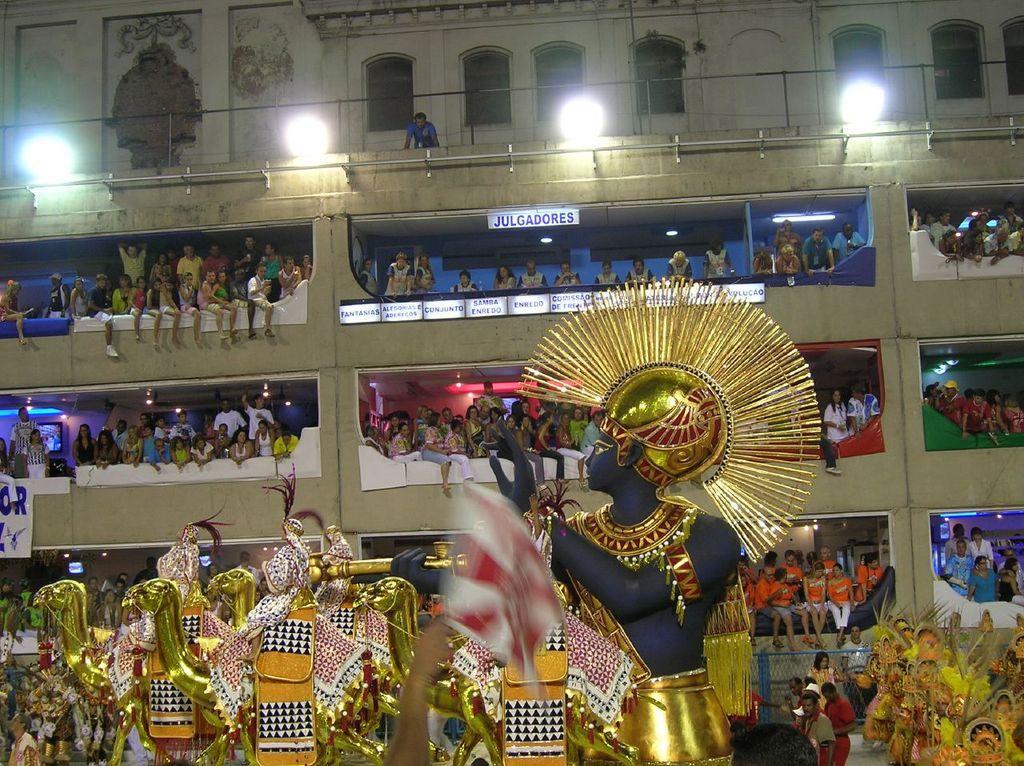Describe this image in one or two sentences. In this image in the middle there are statues, decorations. At the bottom there are people. In the background there are many people, building, lights, walls, windows, posters, text, sign boards and wall. 